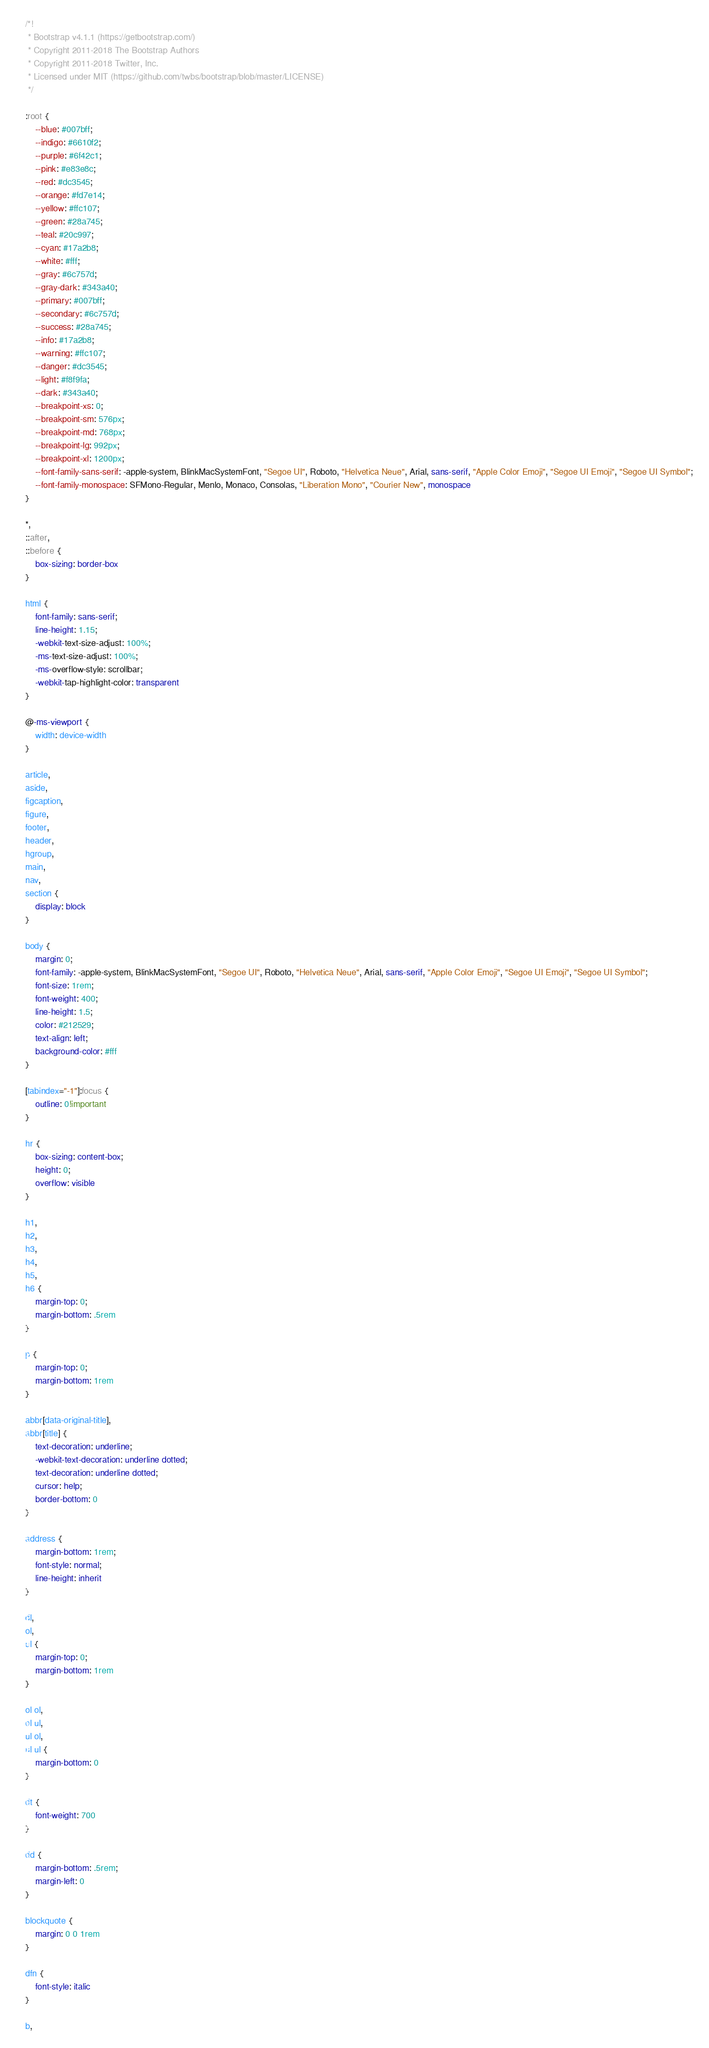Convert code to text. <code><loc_0><loc_0><loc_500><loc_500><_CSS_>/*!
 * Bootstrap v4.1.1 (https://getbootstrap.com/)
 * Copyright 2011-2018 The Bootstrap Authors
 * Copyright 2011-2018 Twitter, Inc.
 * Licensed under MIT (https://github.com/twbs/bootstrap/blob/master/LICENSE)
 */

:root {
    --blue: #007bff;
    --indigo: #6610f2;
    --purple: #6f42c1;
    --pink: #e83e8c;
    --red: #dc3545;
    --orange: #fd7e14;
    --yellow: #ffc107;
    --green: #28a745;
    --teal: #20c997;
    --cyan: #17a2b8;
    --white: #fff;
    --gray: #6c757d;
    --gray-dark: #343a40;
    --primary: #007bff;
    --secondary: #6c757d;
    --success: #28a745;
    --info: #17a2b8;
    --warning: #ffc107;
    --danger: #dc3545;
    --light: #f8f9fa;
    --dark: #343a40;
    --breakpoint-xs: 0;
    --breakpoint-sm: 576px;
    --breakpoint-md: 768px;
    --breakpoint-lg: 992px;
    --breakpoint-xl: 1200px;
    --font-family-sans-serif: -apple-system, BlinkMacSystemFont, "Segoe UI", Roboto, "Helvetica Neue", Arial, sans-serif, "Apple Color Emoji", "Segoe UI Emoji", "Segoe UI Symbol";
    --font-family-monospace: SFMono-Regular, Menlo, Monaco, Consolas, "Liberation Mono", "Courier New", monospace
}

*,
::after,
::before {
    box-sizing: border-box
}

html {
    font-family: sans-serif;
    line-height: 1.15;
    -webkit-text-size-adjust: 100%;
    -ms-text-size-adjust: 100%;
    -ms-overflow-style: scrollbar;
    -webkit-tap-highlight-color: transparent
}

@-ms-viewport {
    width: device-width
}

article,
aside,
figcaption,
figure,
footer,
header,
hgroup,
main,
nav,
section {
    display: block
}

body {
    margin: 0;
    font-family: -apple-system, BlinkMacSystemFont, "Segoe UI", Roboto, "Helvetica Neue", Arial, sans-serif, "Apple Color Emoji", "Segoe UI Emoji", "Segoe UI Symbol";
    font-size: 1rem;
    font-weight: 400;
    line-height: 1.5;
    color: #212529;
    text-align: left;
    background-color: #fff
}

[tabindex="-1"]:focus {
    outline: 0!important
}

hr {
    box-sizing: content-box;
    height: 0;
    overflow: visible
}

h1,
h2,
h3,
h4,
h5,
h6 {
    margin-top: 0;
    margin-bottom: .5rem
}

p {
    margin-top: 0;
    margin-bottom: 1rem
}

abbr[data-original-title],
abbr[title] {
    text-decoration: underline;
    -webkit-text-decoration: underline dotted;
    text-decoration: underline dotted;
    cursor: help;
    border-bottom: 0
}

address {
    margin-bottom: 1rem;
    font-style: normal;
    line-height: inherit
}

dl,
ol,
ul {
    margin-top: 0;
    margin-bottom: 1rem
}

ol ol,
ol ul,
ul ol,
ul ul {
    margin-bottom: 0
}

dt {
    font-weight: 700
}

dd {
    margin-bottom: .5rem;
    margin-left: 0
}

blockquote {
    margin: 0 0 1rem
}

dfn {
    font-style: italic
}

b,</code> 